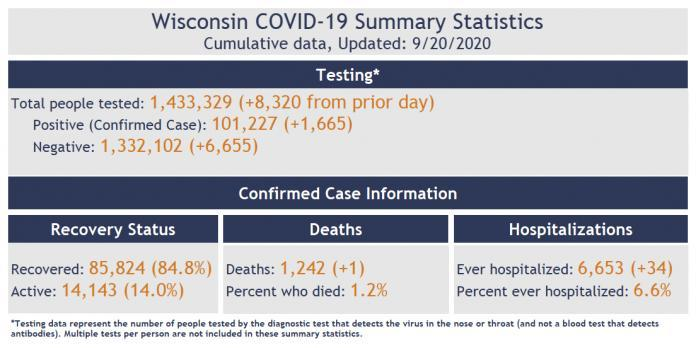How many active COVID-19 cases were there in Wisconsin as of 9/20/2020?
Answer the question with a short phrase. 14,143 What is the percentage of COVID-19 deaths reported in Wisconsin as of 9/20/2020? 1.2% How many recoveries of COVID-19 cases were reported in Wisconsin as of 9/20/2020? 85,824 What percent of the confirmed COVID-19 cases were hospitalized in Wisconsin as of 9/20/2020? 6.6% 